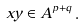<formula> <loc_0><loc_0><loc_500><loc_500>x y \in A ^ { p + q } \, .</formula> 